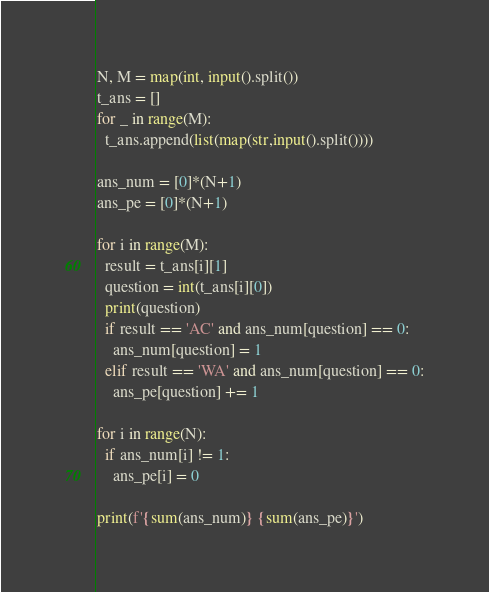<code> <loc_0><loc_0><loc_500><loc_500><_Python_>N, M = map(int, input().split())
t_ans = []
for _ in range(M):
  t_ans.append(list(map(str,input().split())))

ans_num = [0]*(N+1)
ans_pe = [0]*(N+1)

for i in range(M):
  result = t_ans[i][1]
  question = int(t_ans[i][0])
  print(question)
  if result == 'AC' and ans_num[question] == 0:
    ans_num[question] = 1
  elif result == 'WA' and ans_num[question] == 0:
    ans_pe[question] += 1
  
for i in range(N):
  if ans_num[i] != 1:
    ans_pe[i] = 0

print(f'{sum(ans_num)} {sum(ans_pe)}')</code> 